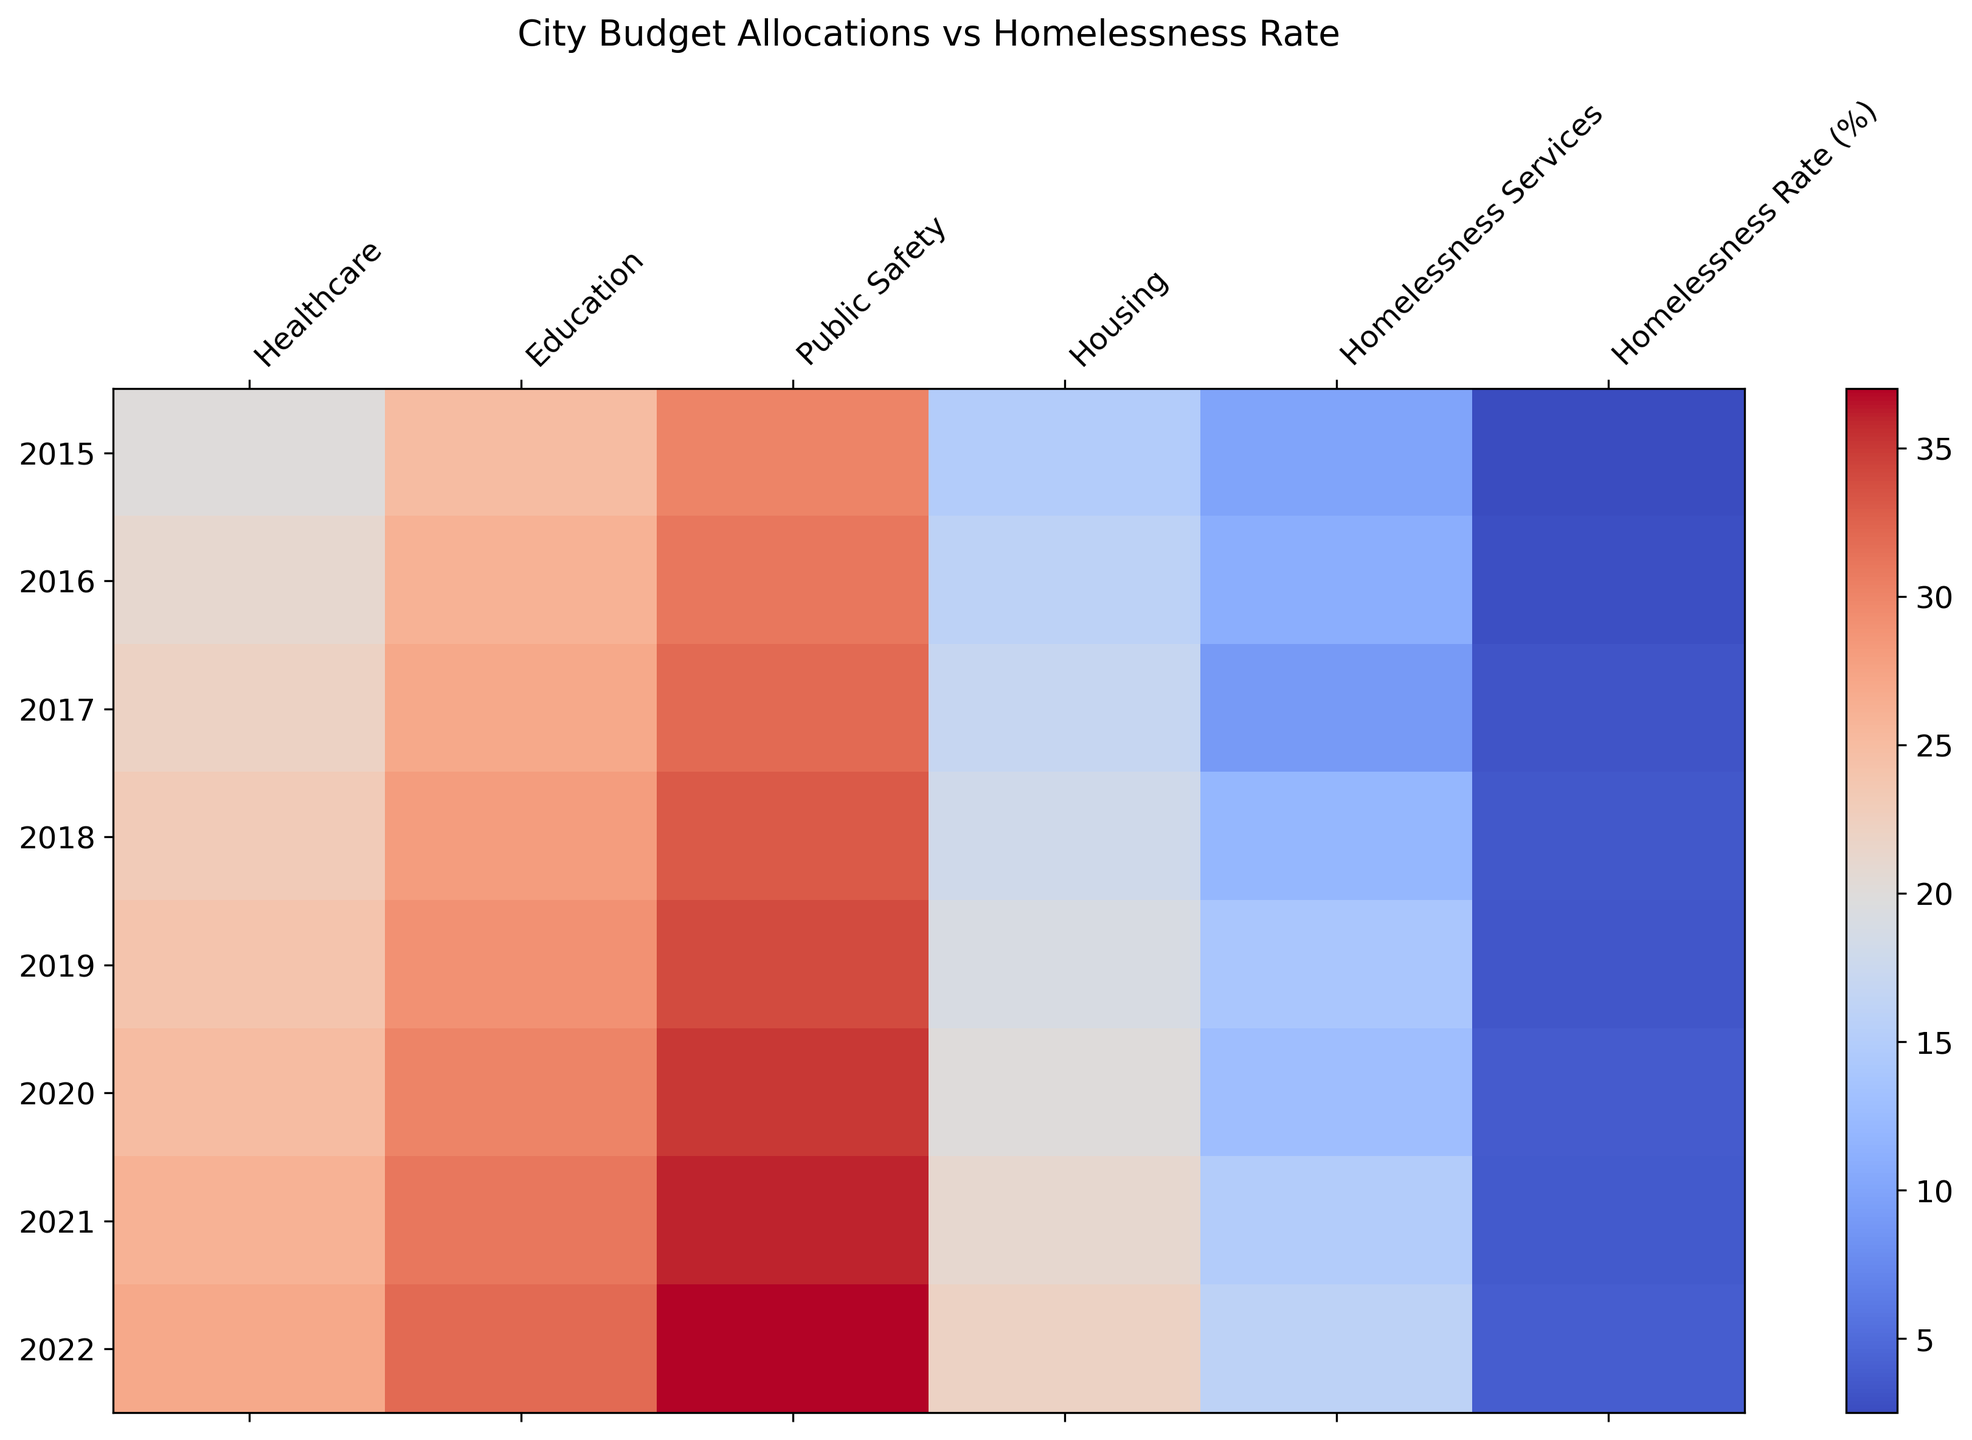What's the overall trend in homelessness rates from 2015 to 2022? By visually inspecting the color intensity changes for the "Homelessness Rate (%)" column in the heatmap from 2015 to 2022, one can see a general increase in the homelessness rate. The deeper colors indicate higher rates.
Answer: Increasing Which year saw the largest increase in spending on Homelessness Services compared to the previous year? By comparing the color changes in the "Homelessness Services" row between consecutive years, the largest jump is from 2017 to 2018 where the color becomes significantly deeper, indicating increased spending.
Answer: 2018 How does the spending on Housing in 2022 compare with the spending on Healthcare in 2020? From the heatmap, locate 2022 under the Housing column and 2020 under the Healthcare column. Visually, these are both of high intensity, indicating similar high spending levels.
Answer: Similar high spending levels Is there any correlation between the increase in the Homelessness Rate and spending on Education? Observe the color progression in both the "Homelessness Rate (%)" and "Education" rows from 2015 to 2022. Despite increased spending on Education, the Homelessness Rate also increases, indicating no clear negative correlation.
Answer: No clear negative correlation What is the ratio of the spending on Public Safety in 2021 to the spending on Homelessness Services in 2018? Identify the colors for "Public Safety" in 2021 and "Homelessness Services" in 2018. Both seem high. Note specific numbers: 36 for Public Safety in 2021 and 12 for Homelessness Services in 2018. The ratio is 36/12.
Answer: 3:1 